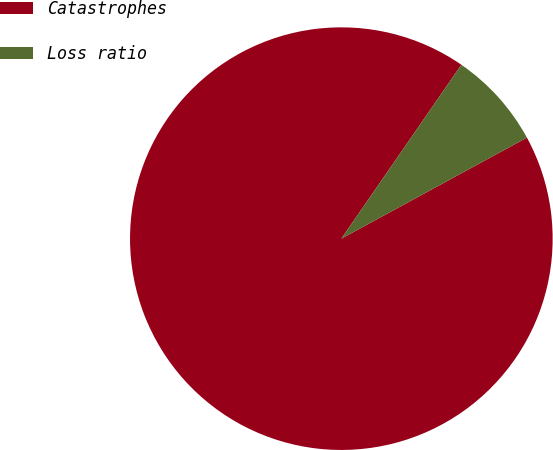Convert chart to OTSL. <chart><loc_0><loc_0><loc_500><loc_500><pie_chart><fcel>Catastrophes<fcel>Loss ratio<nl><fcel>92.55%<fcel>7.45%<nl></chart> 